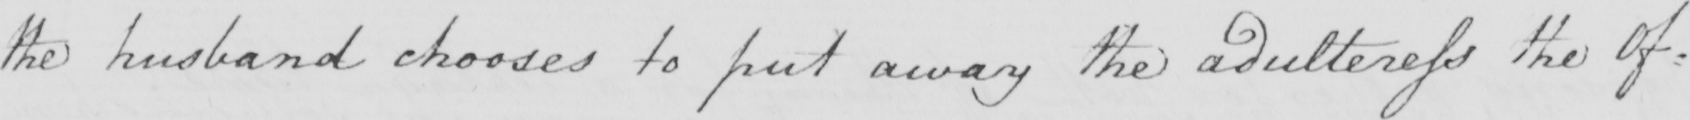Can you read and transcribe this handwriting? the husband chooses to put away the adulteress the Of= 